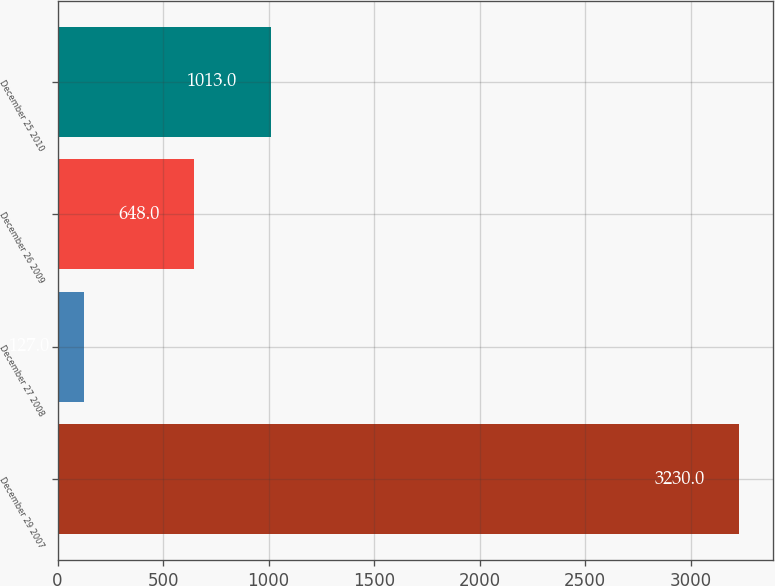<chart> <loc_0><loc_0><loc_500><loc_500><bar_chart><fcel>December 29 2007<fcel>December 27 2008<fcel>December 26 2009<fcel>December 25 2010<nl><fcel>3230<fcel>127<fcel>648<fcel>1013<nl></chart> 